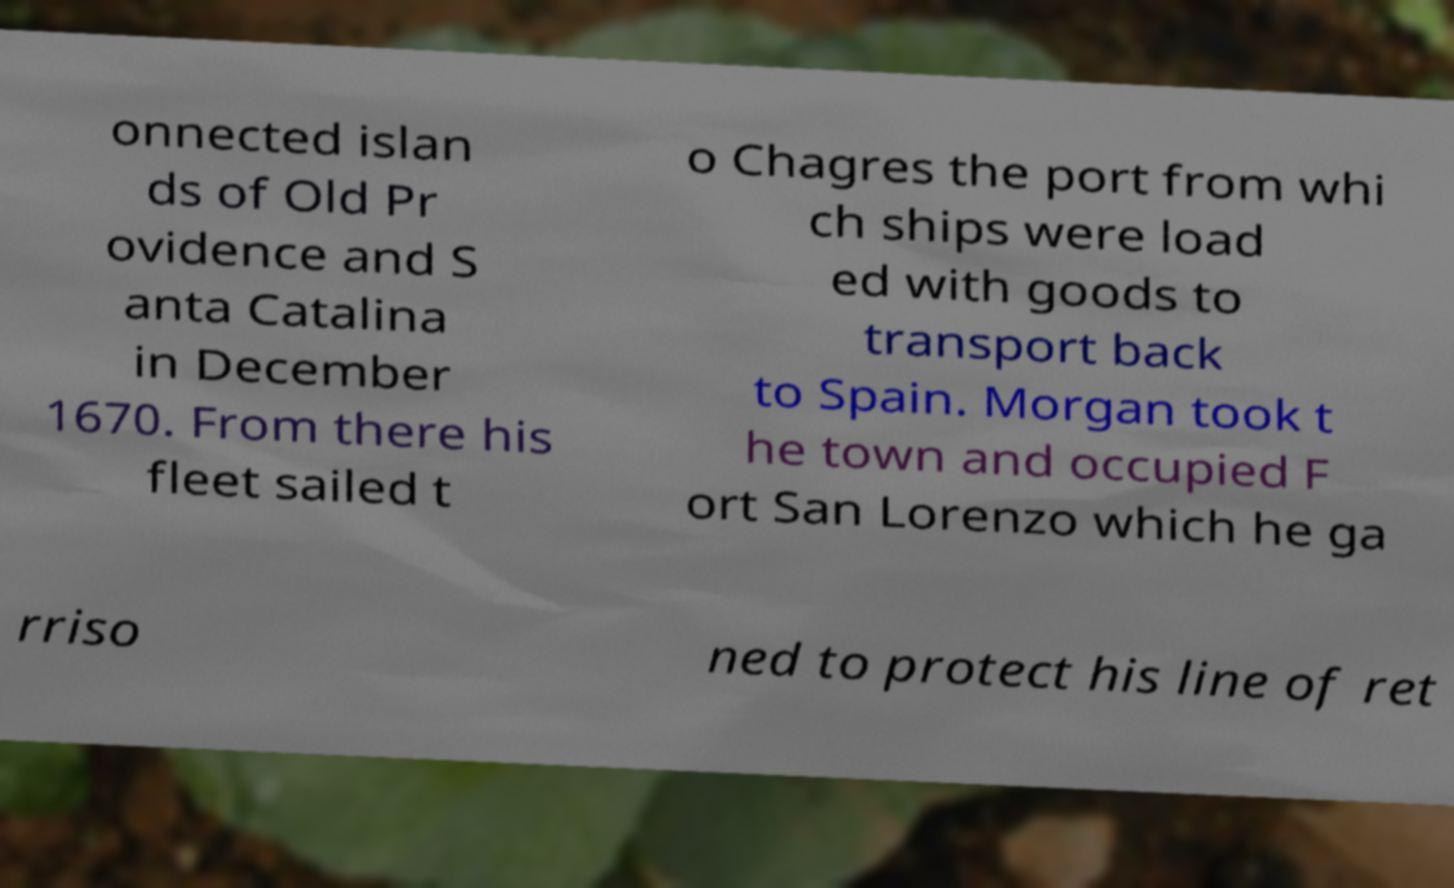Please read and relay the text visible in this image. What does it say? onnected islan ds of Old Pr ovidence and S anta Catalina in December 1670. From there his fleet sailed t o Chagres the port from whi ch ships were load ed with goods to transport back to Spain. Morgan took t he town and occupied F ort San Lorenzo which he ga rriso ned to protect his line of ret 